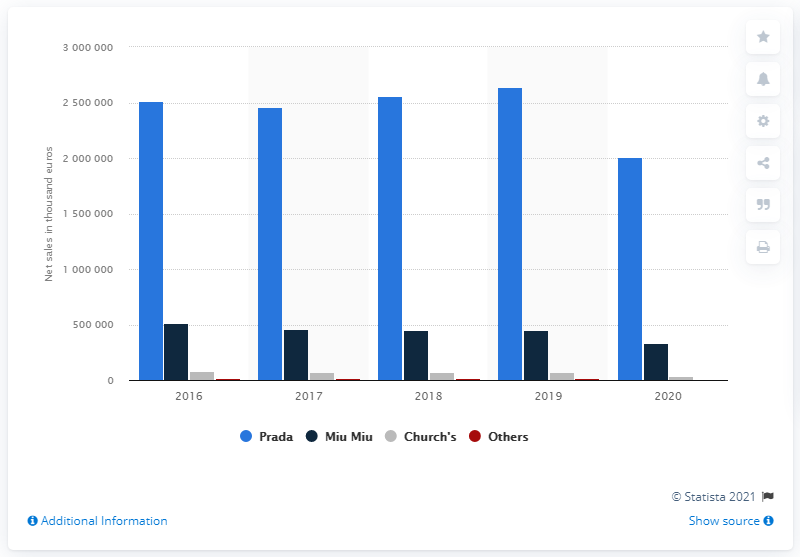Identify some key points in this picture. The second most profitable brand under the Prada Group was Miu Miu. 